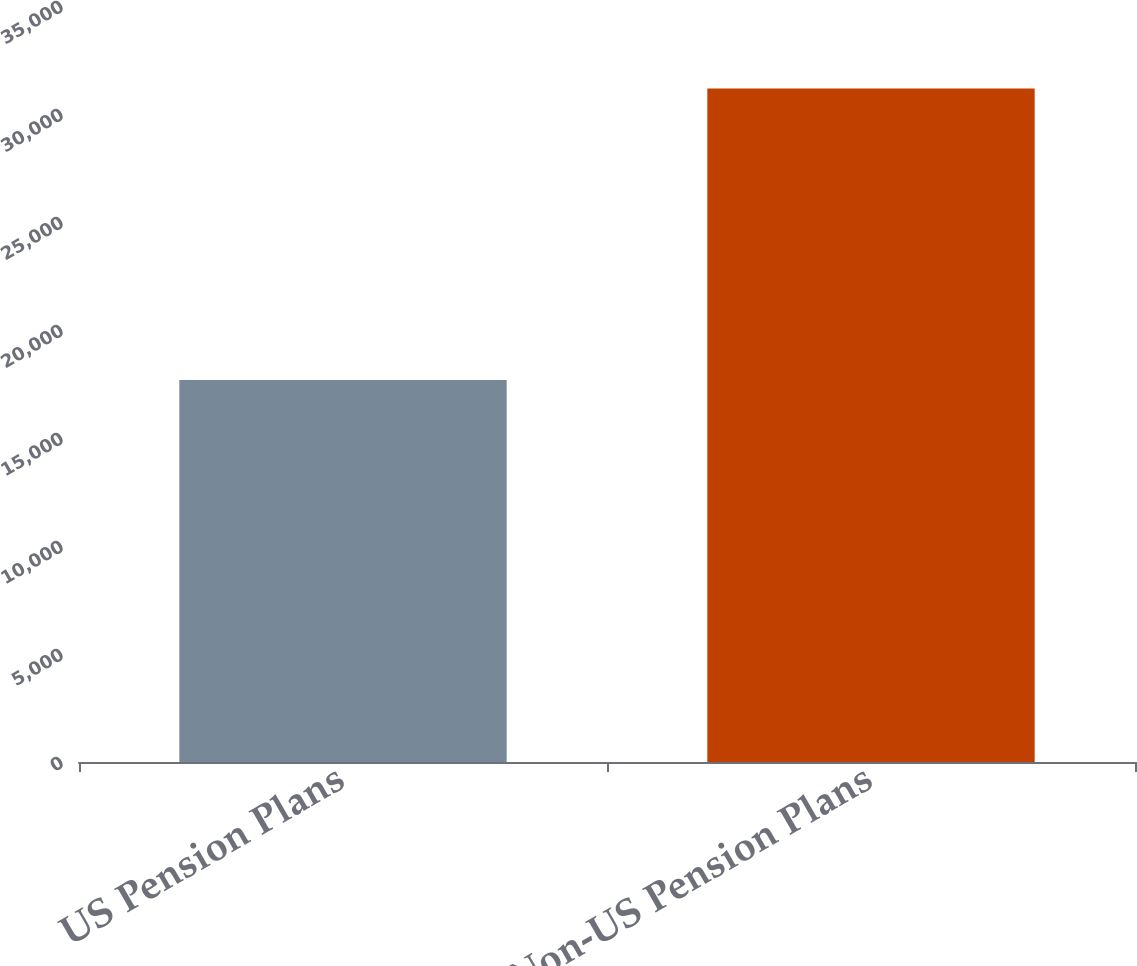<chart> <loc_0><loc_0><loc_500><loc_500><bar_chart><fcel>US Pension Plans<fcel>Non-US Pension Plans<nl><fcel>17687<fcel>31185<nl></chart> 